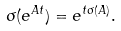Convert formula to latex. <formula><loc_0><loc_0><loc_500><loc_500>\sigma ( e ^ { A t } ) = e ^ { t \sigma ( A ) } .</formula> 